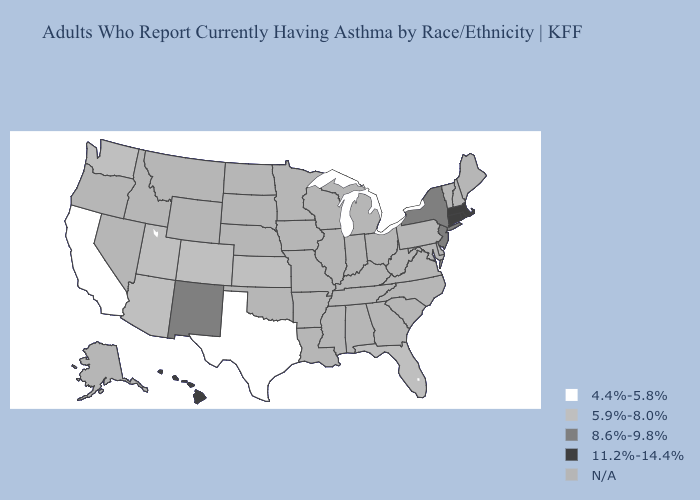Name the states that have a value in the range 8.6%-9.8%?
Write a very short answer. New Jersey, New Mexico, New York. Which states have the lowest value in the Northeast?
Write a very short answer. New Jersey, New York. What is the value of Mississippi?
Answer briefly. N/A. Among the states that border Alabama , which have the lowest value?
Keep it brief. Florida. What is the highest value in the West ?
Give a very brief answer. 11.2%-14.4%. Does Massachusetts have the highest value in the USA?
Be succinct. Yes. What is the lowest value in the South?
Keep it brief. 4.4%-5.8%. Does Utah have the lowest value in the West?
Short answer required. No. Does Texas have the lowest value in the USA?
Write a very short answer. Yes. What is the lowest value in the USA?
Write a very short answer. 4.4%-5.8%. 